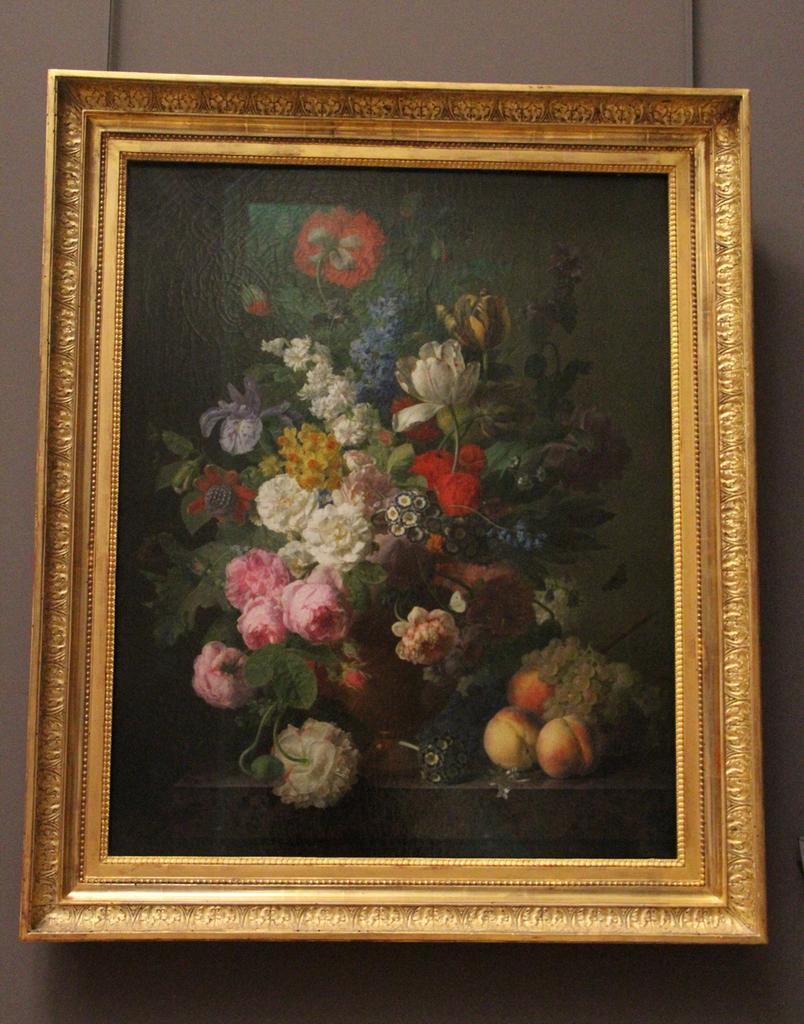How would you summarize this image in a sentence or two? In this picture we can see a frame. In this frame, we can see some colorful flowers and fruits. 